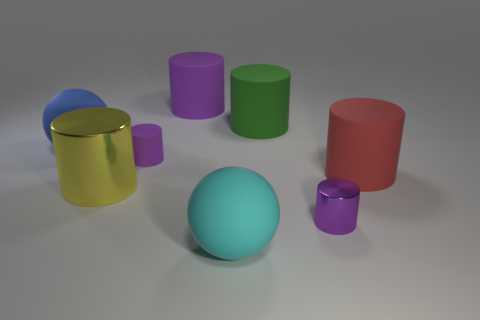What number of things are large yellow metallic cylinders or things in front of the red matte object? There are two large yellow metallic cylinders and one small purple cylinder in front of the red matte object, making the total number of cylinders three. 